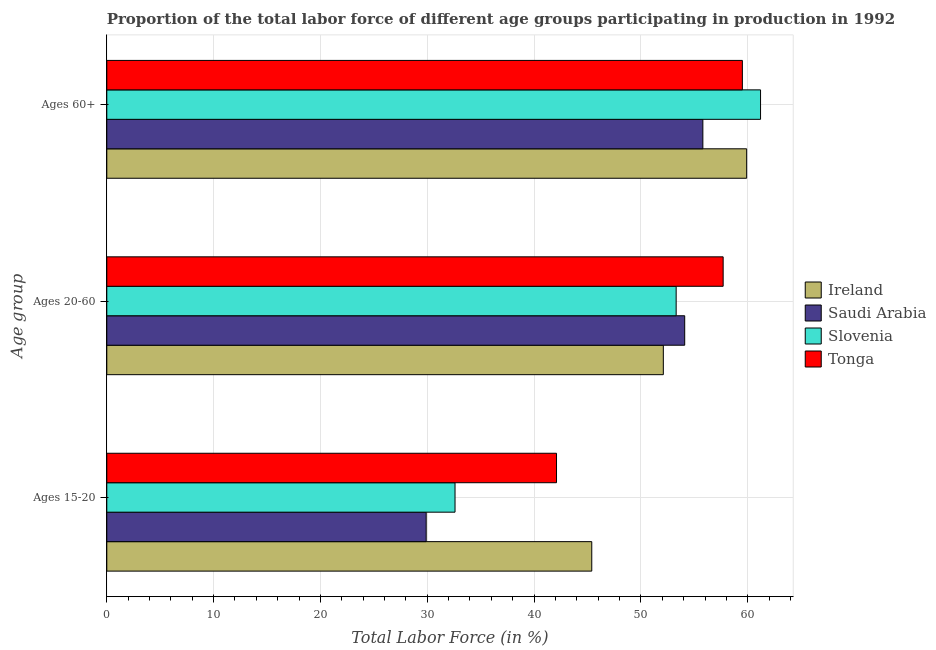How many groups of bars are there?
Provide a short and direct response. 3. Are the number of bars per tick equal to the number of legend labels?
Offer a very short reply. Yes. How many bars are there on the 2nd tick from the top?
Make the answer very short. 4. What is the label of the 2nd group of bars from the top?
Your response must be concise. Ages 20-60. What is the percentage of labor force within the age group 15-20 in Slovenia?
Provide a short and direct response. 32.6. Across all countries, what is the maximum percentage of labor force within the age group 20-60?
Ensure brevity in your answer.  57.7. Across all countries, what is the minimum percentage of labor force within the age group 15-20?
Your response must be concise. 29.9. In which country was the percentage of labor force above age 60 maximum?
Your answer should be compact. Slovenia. In which country was the percentage of labor force within the age group 20-60 minimum?
Give a very brief answer. Ireland. What is the total percentage of labor force within the age group 15-20 in the graph?
Keep it short and to the point. 150. What is the difference between the percentage of labor force within the age group 20-60 in Tonga and that in Slovenia?
Offer a very short reply. 4.4. What is the difference between the percentage of labor force above age 60 in Tonga and the percentage of labor force within the age group 20-60 in Ireland?
Keep it short and to the point. 7.4. What is the average percentage of labor force above age 60 per country?
Make the answer very short. 59.1. What is the difference between the percentage of labor force above age 60 and percentage of labor force within the age group 20-60 in Ireland?
Your response must be concise. 7.8. What is the ratio of the percentage of labor force within the age group 15-20 in Ireland to that in Tonga?
Make the answer very short. 1.08. Is the difference between the percentage of labor force within the age group 20-60 in Tonga and Ireland greater than the difference between the percentage of labor force above age 60 in Tonga and Ireland?
Offer a terse response. Yes. What is the difference between the highest and the second highest percentage of labor force above age 60?
Make the answer very short. 1.3. What is the difference between the highest and the lowest percentage of labor force above age 60?
Keep it short and to the point. 5.4. What does the 2nd bar from the top in Ages 60+ represents?
Your answer should be very brief. Slovenia. What does the 1st bar from the bottom in Ages 15-20 represents?
Offer a very short reply. Ireland. Is it the case that in every country, the sum of the percentage of labor force within the age group 15-20 and percentage of labor force within the age group 20-60 is greater than the percentage of labor force above age 60?
Ensure brevity in your answer.  Yes. What is the difference between two consecutive major ticks on the X-axis?
Keep it short and to the point. 10. Does the graph contain any zero values?
Provide a short and direct response. No. Where does the legend appear in the graph?
Offer a terse response. Center right. How many legend labels are there?
Your answer should be compact. 4. How are the legend labels stacked?
Provide a short and direct response. Vertical. What is the title of the graph?
Provide a short and direct response. Proportion of the total labor force of different age groups participating in production in 1992. Does "Belarus" appear as one of the legend labels in the graph?
Offer a very short reply. No. What is the label or title of the X-axis?
Ensure brevity in your answer.  Total Labor Force (in %). What is the label or title of the Y-axis?
Keep it short and to the point. Age group. What is the Total Labor Force (in %) in Ireland in Ages 15-20?
Offer a very short reply. 45.4. What is the Total Labor Force (in %) in Saudi Arabia in Ages 15-20?
Provide a short and direct response. 29.9. What is the Total Labor Force (in %) of Slovenia in Ages 15-20?
Your response must be concise. 32.6. What is the Total Labor Force (in %) of Tonga in Ages 15-20?
Keep it short and to the point. 42.1. What is the Total Labor Force (in %) in Ireland in Ages 20-60?
Give a very brief answer. 52.1. What is the Total Labor Force (in %) of Saudi Arabia in Ages 20-60?
Your answer should be compact. 54.1. What is the Total Labor Force (in %) of Slovenia in Ages 20-60?
Ensure brevity in your answer.  53.3. What is the Total Labor Force (in %) in Tonga in Ages 20-60?
Offer a terse response. 57.7. What is the Total Labor Force (in %) in Ireland in Ages 60+?
Give a very brief answer. 59.9. What is the Total Labor Force (in %) in Saudi Arabia in Ages 60+?
Give a very brief answer. 55.8. What is the Total Labor Force (in %) in Slovenia in Ages 60+?
Give a very brief answer. 61.2. What is the Total Labor Force (in %) in Tonga in Ages 60+?
Provide a short and direct response. 59.5. Across all Age group, what is the maximum Total Labor Force (in %) of Ireland?
Your answer should be compact. 59.9. Across all Age group, what is the maximum Total Labor Force (in %) of Saudi Arabia?
Provide a succinct answer. 55.8. Across all Age group, what is the maximum Total Labor Force (in %) of Slovenia?
Give a very brief answer. 61.2. Across all Age group, what is the maximum Total Labor Force (in %) in Tonga?
Provide a succinct answer. 59.5. Across all Age group, what is the minimum Total Labor Force (in %) in Ireland?
Your answer should be compact. 45.4. Across all Age group, what is the minimum Total Labor Force (in %) in Saudi Arabia?
Give a very brief answer. 29.9. Across all Age group, what is the minimum Total Labor Force (in %) in Slovenia?
Give a very brief answer. 32.6. Across all Age group, what is the minimum Total Labor Force (in %) of Tonga?
Your answer should be very brief. 42.1. What is the total Total Labor Force (in %) of Ireland in the graph?
Provide a short and direct response. 157.4. What is the total Total Labor Force (in %) of Saudi Arabia in the graph?
Offer a very short reply. 139.8. What is the total Total Labor Force (in %) of Slovenia in the graph?
Provide a short and direct response. 147.1. What is the total Total Labor Force (in %) of Tonga in the graph?
Provide a succinct answer. 159.3. What is the difference between the Total Labor Force (in %) of Ireland in Ages 15-20 and that in Ages 20-60?
Give a very brief answer. -6.7. What is the difference between the Total Labor Force (in %) in Saudi Arabia in Ages 15-20 and that in Ages 20-60?
Keep it short and to the point. -24.2. What is the difference between the Total Labor Force (in %) of Slovenia in Ages 15-20 and that in Ages 20-60?
Your answer should be very brief. -20.7. What is the difference between the Total Labor Force (in %) of Tonga in Ages 15-20 and that in Ages 20-60?
Offer a terse response. -15.6. What is the difference between the Total Labor Force (in %) of Ireland in Ages 15-20 and that in Ages 60+?
Give a very brief answer. -14.5. What is the difference between the Total Labor Force (in %) of Saudi Arabia in Ages 15-20 and that in Ages 60+?
Your answer should be compact. -25.9. What is the difference between the Total Labor Force (in %) in Slovenia in Ages 15-20 and that in Ages 60+?
Your answer should be very brief. -28.6. What is the difference between the Total Labor Force (in %) in Tonga in Ages 15-20 and that in Ages 60+?
Provide a succinct answer. -17.4. What is the difference between the Total Labor Force (in %) of Slovenia in Ages 20-60 and that in Ages 60+?
Ensure brevity in your answer.  -7.9. What is the difference between the Total Labor Force (in %) in Tonga in Ages 20-60 and that in Ages 60+?
Your answer should be compact. -1.8. What is the difference between the Total Labor Force (in %) in Ireland in Ages 15-20 and the Total Labor Force (in %) in Saudi Arabia in Ages 20-60?
Offer a very short reply. -8.7. What is the difference between the Total Labor Force (in %) in Ireland in Ages 15-20 and the Total Labor Force (in %) in Tonga in Ages 20-60?
Your response must be concise. -12.3. What is the difference between the Total Labor Force (in %) of Saudi Arabia in Ages 15-20 and the Total Labor Force (in %) of Slovenia in Ages 20-60?
Your answer should be compact. -23.4. What is the difference between the Total Labor Force (in %) of Saudi Arabia in Ages 15-20 and the Total Labor Force (in %) of Tonga in Ages 20-60?
Make the answer very short. -27.8. What is the difference between the Total Labor Force (in %) in Slovenia in Ages 15-20 and the Total Labor Force (in %) in Tonga in Ages 20-60?
Offer a terse response. -25.1. What is the difference between the Total Labor Force (in %) of Ireland in Ages 15-20 and the Total Labor Force (in %) of Saudi Arabia in Ages 60+?
Offer a terse response. -10.4. What is the difference between the Total Labor Force (in %) of Ireland in Ages 15-20 and the Total Labor Force (in %) of Slovenia in Ages 60+?
Your response must be concise. -15.8. What is the difference between the Total Labor Force (in %) of Ireland in Ages 15-20 and the Total Labor Force (in %) of Tonga in Ages 60+?
Make the answer very short. -14.1. What is the difference between the Total Labor Force (in %) in Saudi Arabia in Ages 15-20 and the Total Labor Force (in %) in Slovenia in Ages 60+?
Your answer should be compact. -31.3. What is the difference between the Total Labor Force (in %) in Saudi Arabia in Ages 15-20 and the Total Labor Force (in %) in Tonga in Ages 60+?
Offer a very short reply. -29.6. What is the difference between the Total Labor Force (in %) in Slovenia in Ages 15-20 and the Total Labor Force (in %) in Tonga in Ages 60+?
Ensure brevity in your answer.  -26.9. What is the difference between the Total Labor Force (in %) of Ireland in Ages 20-60 and the Total Labor Force (in %) of Saudi Arabia in Ages 60+?
Make the answer very short. -3.7. What is the difference between the Total Labor Force (in %) of Ireland in Ages 20-60 and the Total Labor Force (in %) of Slovenia in Ages 60+?
Make the answer very short. -9.1. What is the difference between the Total Labor Force (in %) in Ireland in Ages 20-60 and the Total Labor Force (in %) in Tonga in Ages 60+?
Your answer should be very brief. -7.4. What is the difference between the Total Labor Force (in %) in Slovenia in Ages 20-60 and the Total Labor Force (in %) in Tonga in Ages 60+?
Provide a succinct answer. -6.2. What is the average Total Labor Force (in %) in Ireland per Age group?
Ensure brevity in your answer.  52.47. What is the average Total Labor Force (in %) of Saudi Arabia per Age group?
Offer a very short reply. 46.6. What is the average Total Labor Force (in %) of Slovenia per Age group?
Provide a succinct answer. 49.03. What is the average Total Labor Force (in %) in Tonga per Age group?
Ensure brevity in your answer.  53.1. What is the difference between the Total Labor Force (in %) of Ireland and Total Labor Force (in %) of Saudi Arabia in Ages 15-20?
Make the answer very short. 15.5. What is the difference between the Total Labor Force (in %) of Saudi Arabia and Total Labor Force (in %) of Slovenia in Ages 20-60?
Your response must be concise. 0.8. What is the difference between the Total Labor Force (in %) of Ireland and Total Labor Force (in %) of Saudi Arabia in Ages 60+?
Give a very brief answer. 4.1. What is the difference between the Total Labor Force (in %) in Saudi Arabia and Total Labor Force (in %) in Tonga in Ages 60+?
Your response must be concise. -3.7. What is the ratio of the Total Labor Force (in %) in Ireland in Ages 15-20 to that in Ages 20-60?
Your response must be concise. 0.87. What is the ratio of the Total Labor Force (in %) in Saudi Arabia in Ages 15-20 to that in Ages 20-60?
Provide a short and direct response. 0.55. What is the ratio of the Total Labor Force (in %) of Slovenia in Ages 15-20 to that in Ages 20-60?
Offer a terse response. 0.61. What is the ratio of the Total Labor Force (in %) in Tonga in Ages 15-20 to that in Ages 20-60?
Keep it short and to the point. 0.73. What is the ratio of the Total Labor Force (in %) in Ireland in Ages 15-20 to that in Ages 60+?
Keep it short and to the point. 0.76. What is the ratio of the Total Labor Force (in %) in Saudi Arabia in Ages 15-20 to that in Ages 60+?
Offer a very short reply. 0.54. What is the ratio of the Total Labor Force (in %) of Slovenia in Ages 15-20 to that in Ages 60+?
Offer a terse response. 0.53. What is the ratio of the Total Labor Force (in %) of Tonga in Ages 15-20 to that in Ages 60+?
Your answer should be compact. 0.71. What is the ratio of the Total Labor Force (in %) of Ireland in Ages 20-60 to that in Ages 60+?
Ensure brevity in your answer.  0.87. What is the ratio of the Total Labor Force (in %) in Saudi Arabia in Ages 20-60 to that in Ages 60+?
Your response must be concise. 0.97. What is the ratio of the Total Labor Force (in %) of Slovenia in Ages 20-60 to that in Ages 60+?
Offer a terse response. 0.87. What is the ratio of the Total Labor Force (in %) of Tonga in Ages 20-60 to that in Ages 60+?
Offer a very short reply. 0.97. What is the difference between the highest and the second highest Total Labor Force (in %) in Ireland?
Give a very brief answer. 7.8. What is the difference between the highest and the lowest Total Labor Force (in %) of Saudi Arabia?
Make the answer very short. 25.9. What is the difference between the highest and the lowest Total Labor Force (in %) in Slovenia?
Your response must be concise. 28.6. 